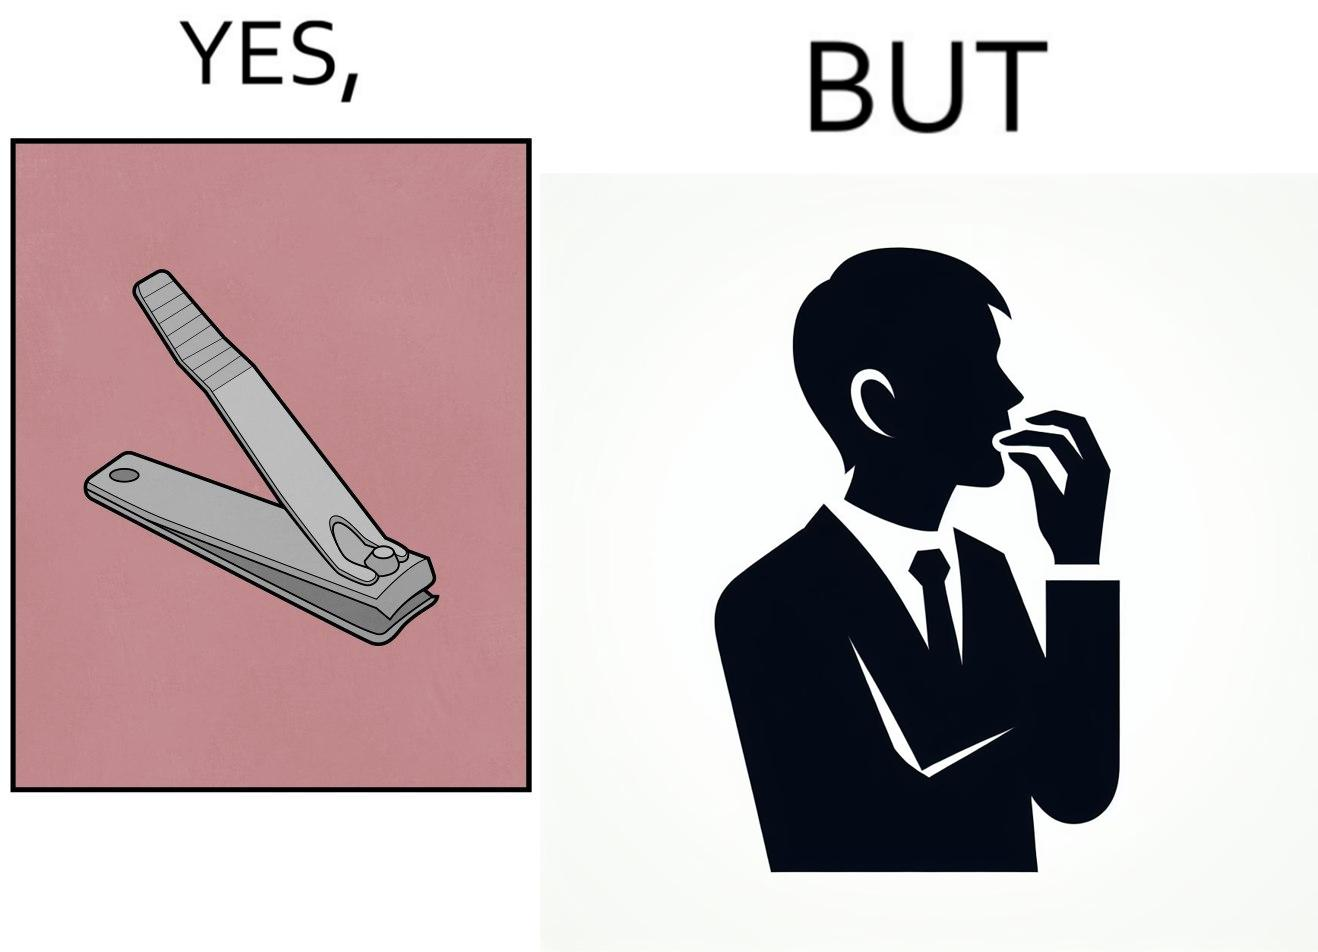Is this a satirical image? Yes, this image is satirical. 